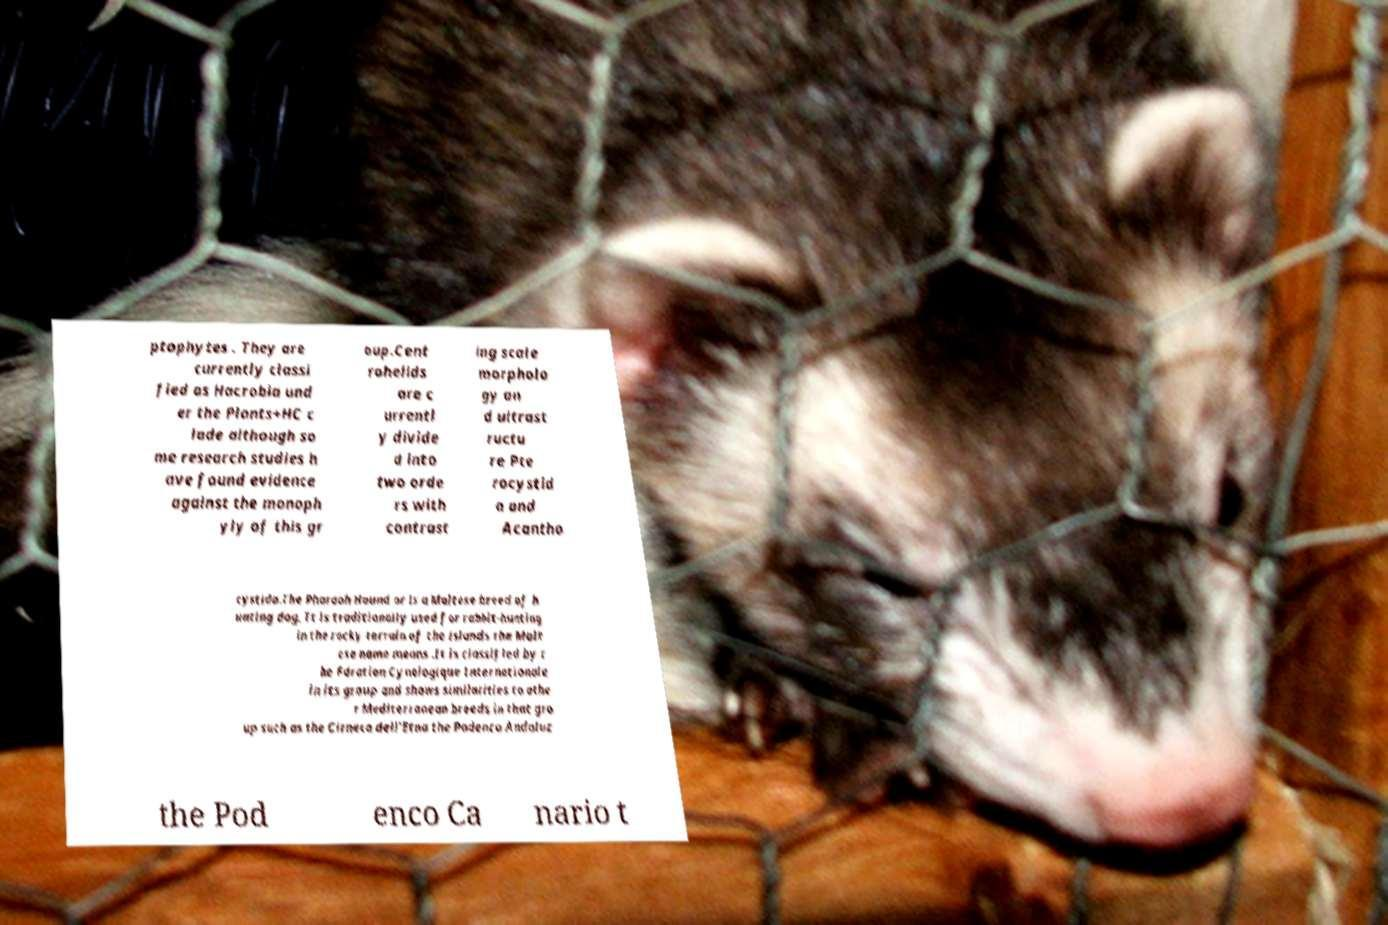Please identify and transcribe the text found in this image. ptophytes . They are currently classi fied as Hacrobia und er the Plants+HC c lade although so me research studies h ave found evidence against the monoph yly of this gr oup.Cent rohelids are c urrentl y divide d into two orde rs with contrast ing scale morpholo gy an d ultrast ructu re Pte rocystid a and Acantho cystida.The Pharaoh Hound or is a Maltese breed of h unting dog. It is traditionally used for rabbit-hunting in the rocky terrain of the islands the Malt ese name means .It is classified by t he Fdration Cynologique Internationale in its group and shows similarities to othe r Mediterranean breeds in that gro up such as the Cirneco dell'Etna the Podenco Andaluz the Pod enco Ca nario t 